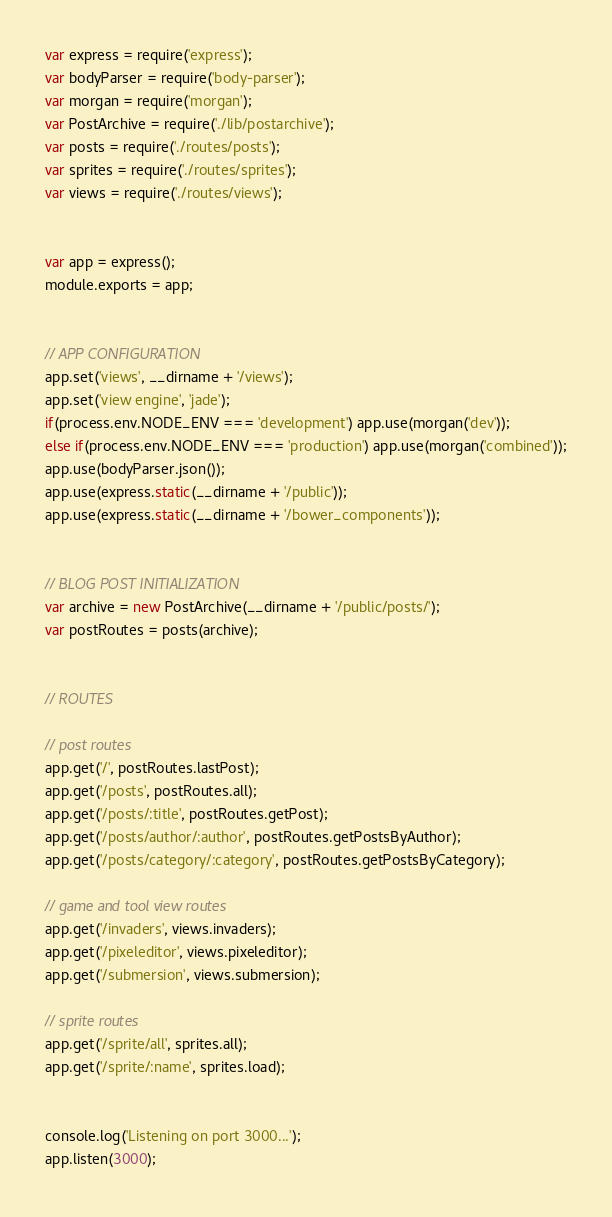Convert code to text. <code><loc_0><loc_0><loc_500><loc_500><_JavaScript_>var express = require('express');
var bodyParser = require('body-parser');
var morgan = require('morgan');
var PostArchive = require('./lib/postarchive');
var posts = require('./routes/posts');
var sprites = require('./routes/sprites');
var views = require('./routes/views');


var app = express();
module.exports = app;


// APP CONFIGURATION
app.set('views', __dirname + '/views');
app.set('view engine', 'jade');
if(process.env.NODE_ENV === 'development') app.use(morgan('dev'));
else if(process.env.NODE_ENV === 'production') app.use(morgan('combined'));
app.use(bodyParser.json());
app.use(express.static(__dirname + '/public'));
app.use(express.static(__dirname + '/bower_components'));


// BLOG POST INITIALIZATION
var archive = new PostArchive(__dirname + '/public/posts/');
var postRoutes = posts(archive);


// ROUTES

// post routes
app.get('/', postRoutes.lastPost);
app.get('/posts', postRoutes.all);
app.get('/posts/:title', postRoutes.getPost);
app.get('/posts/author/:author', postRoutes.getPostsByAuthor);
app.get('/posts/category/:category', postRoutes.getPostsByCategory);

// game and tool view routes
app.get('/invaders', views.invaders);
app.get('/pixeleditor', views.pixeleditor);
app.get('/submersion', views.submersion);

// sprite routes
app.get('/sprite/all', sprites.all);
app.get('/sprite/:name', sprites.load);


console.log('Listening on port 3000...');
app.listen(3000);
</code> 